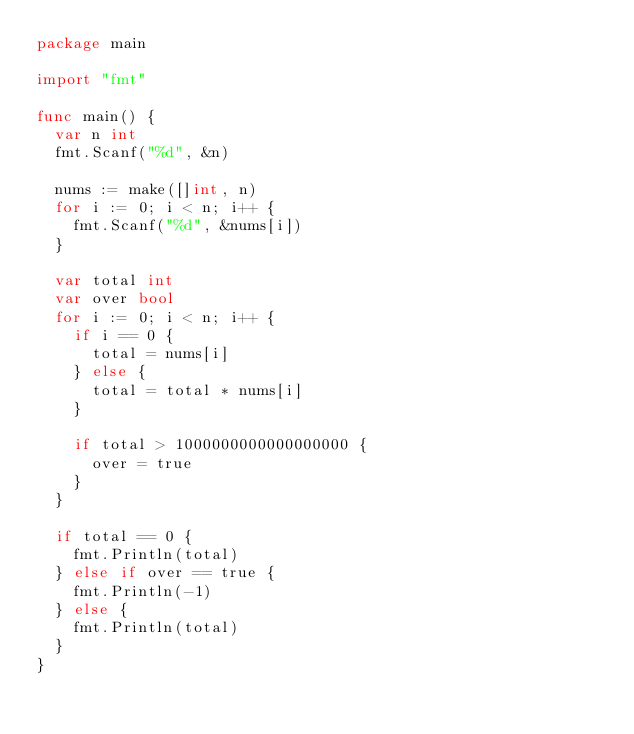<code> <loc_0><loc_0><loc_500><loc_500><_Go_>package main

import "fmt"

func main() {
	var n int
	fmt.Scanf("%d", &n)

	nums := make([]int, n)
	for i := 0; i < n; i++ {
		fmt.Scanf("%d", &nums[i])
	}

	var total int
	var over bool
	for i := 0; i < n; i++ {
		if i == 0 {
			total = nums[i]
		} else {
			total = total * nums[i]
		}

		if total > 1000000000000000000 {
			over = true
		}
	}

	if total == 0 {
		fmt.Println(total)
	} else if over == true {
		fmt.Println(-1)
	} else {
		fmt.Println(total)
	}
}</code> 